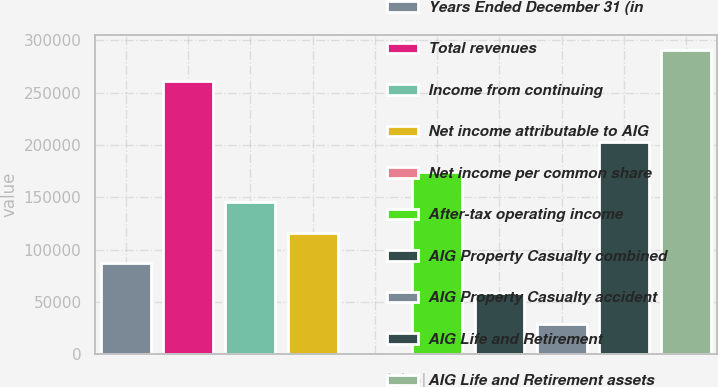Convert chart. <chart><loc_0><loc_0><loc_500><loc_500><bar_chart><fcel>Years Ended December 31 (in<fcel>Total revenues<fcel>Income from continuing<fcel>Net income attributable to AIG<fcel>Net income per common share<fcel>After-tax operating income<fcel>AIG Property Casualty combined<fcel>AIG Property Casualty accident<fcel>AIG Life and Retirement<fcel>AIG Life and Retirement assets<nl><fcel>87117.5<fcel>261349<fcel>145195<fcel>116156<fcel>2.04<fcel>174233<fcel>58079<fcel>29040.5<fcel>203272<fcel>290387<nl></chart> 